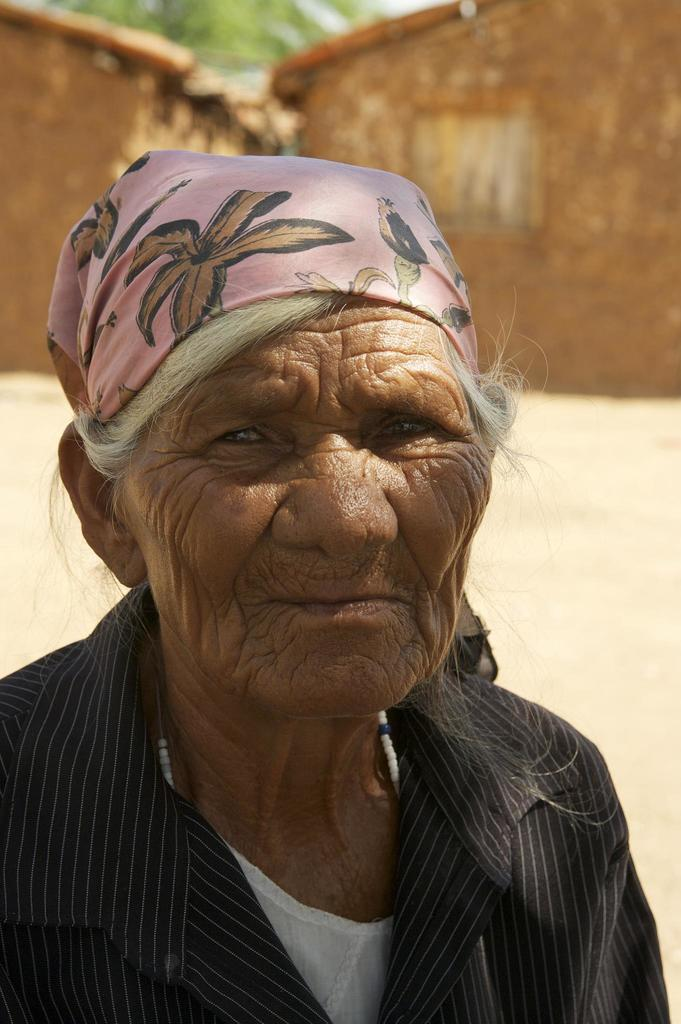Who is the main subject in the image? There is an old woman in the image. What is the old woman wearing? The old woman is wearing a black shirt. What can be seen behind the old woman? There are two horses behind the woman. What type of jewel can be seen on the roof in the image? There is no roof or jewel present in the image. 